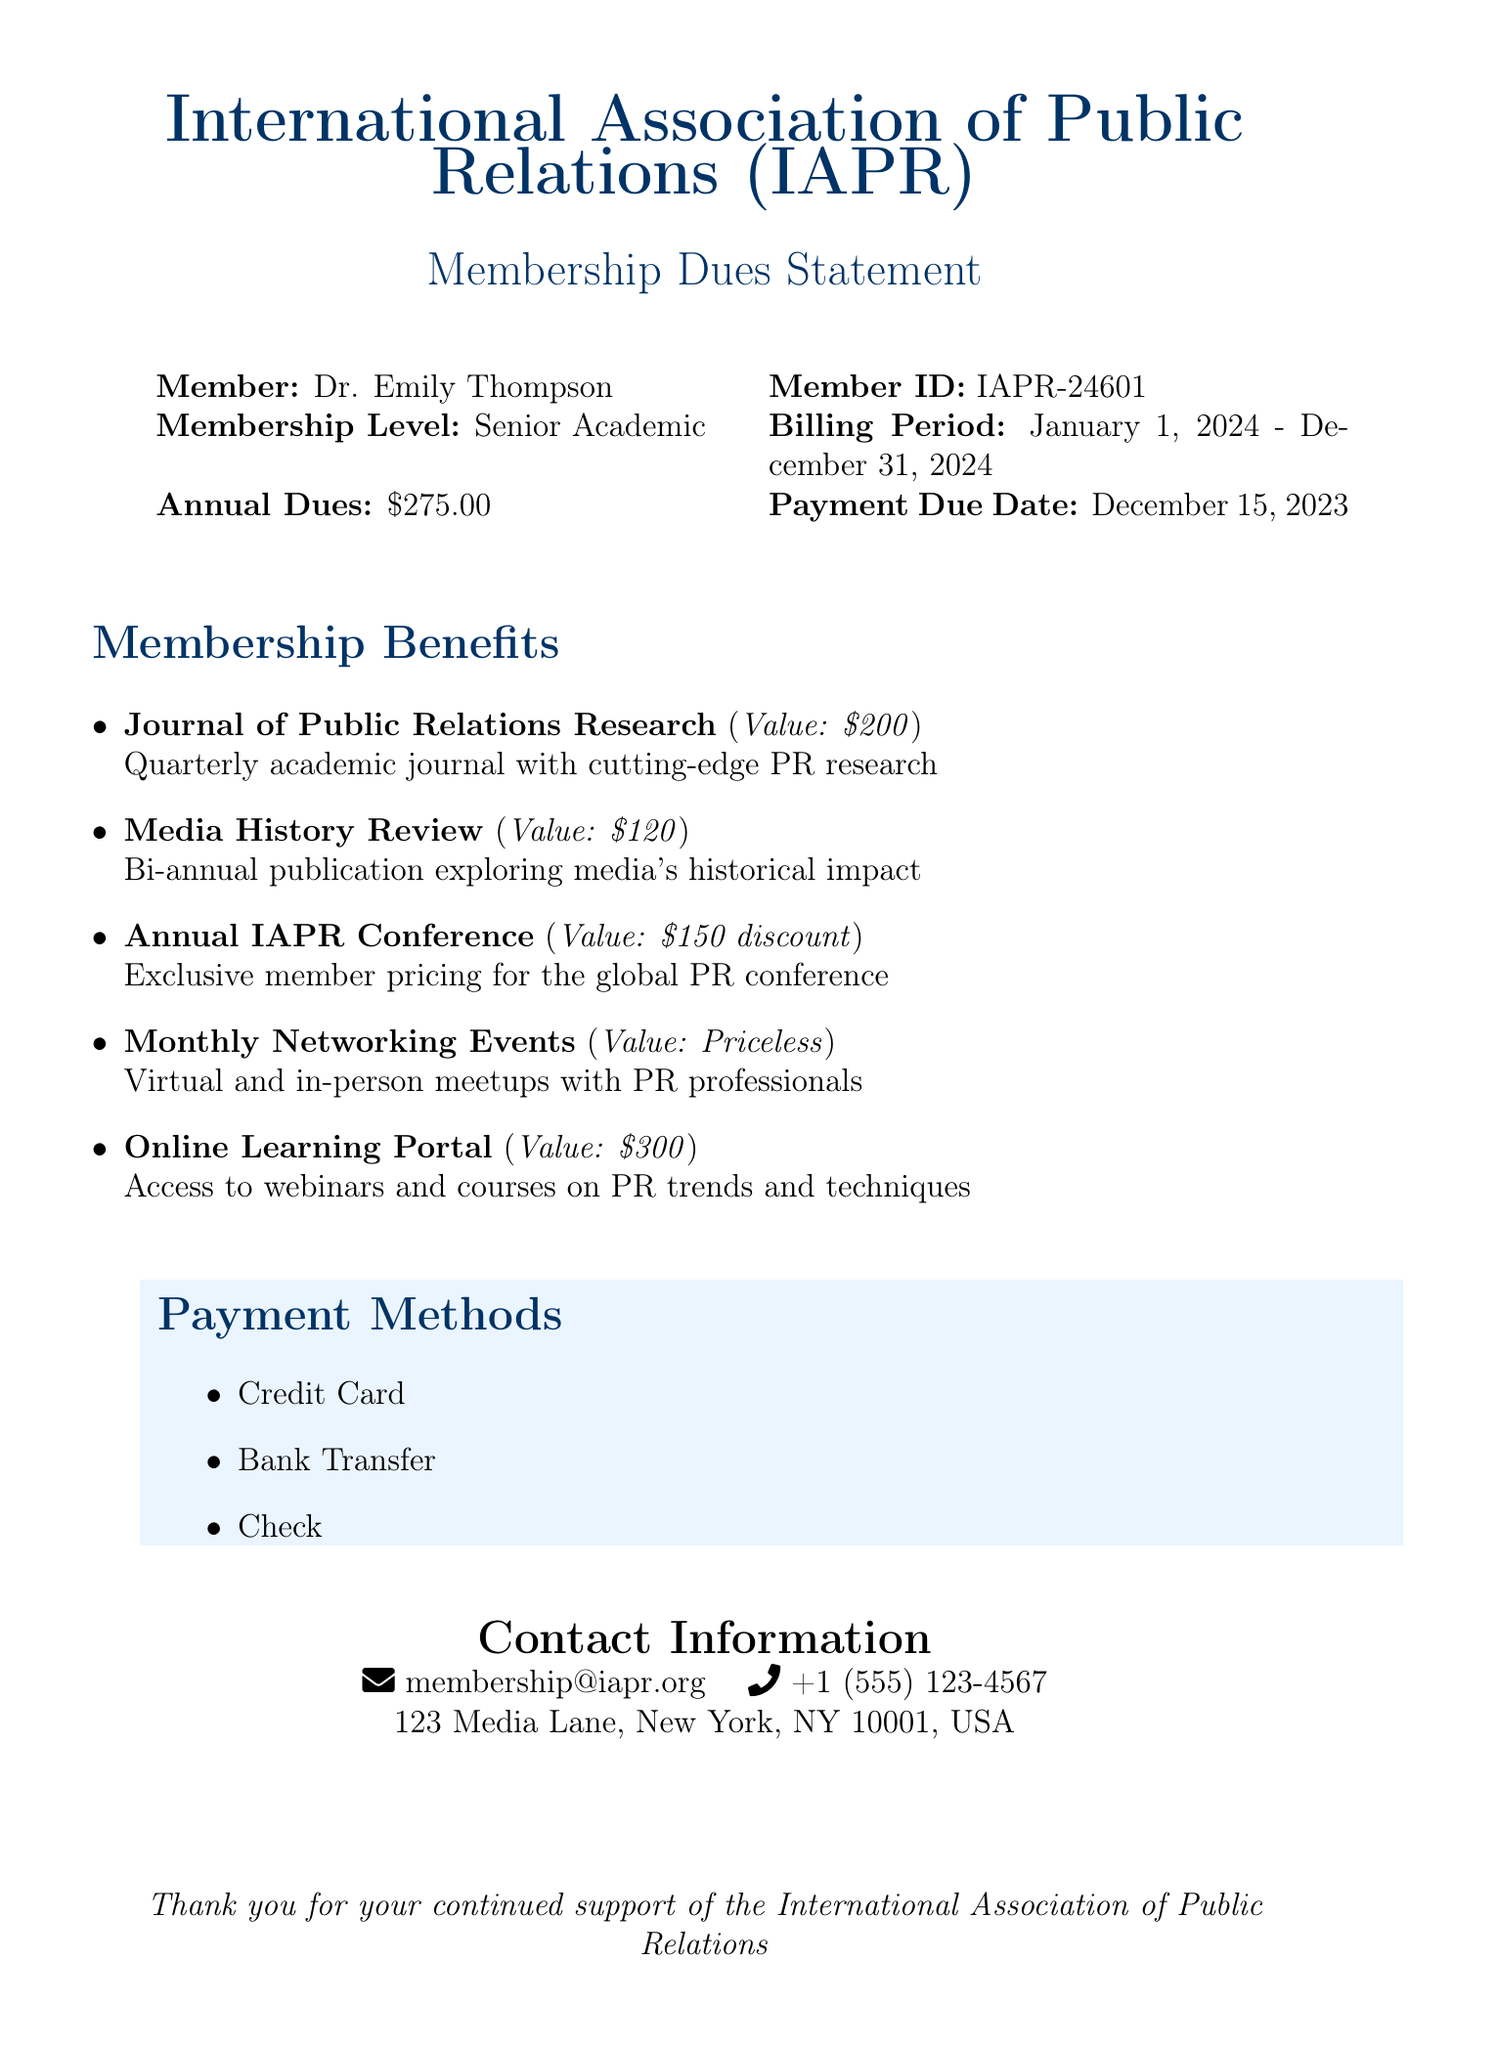What are the annual dues? The annual dues listed in the document are explicitly stated as $275.00.
Answer: $275.00 What is the billing period? The document specifies the billing period as January 1, 2024 - December 31, 2024.
Answer: January 1, 2024 - December 31, 2024 What is one benefit from the membership? The document lists multiple benefits; "Journal of Public Relations Research" is one of them.
Answer: Journal of Public Relations Research What is the payment due date? The date when payment is due is provided as December 15, 2023.
Answer: December 15, 2023 What discount do members receive for the Annual IAPR Conference? The document mentions a discount of $150 for members attending the conference.
Answer: $150 discount How often is the Media History Review published? The document indicates that it is published bi-annually.
Answer: Bi-annual What is the contact email provided in the document? The email listed for membership inquiries is mentioned as membership@iapr.org.
Answer: membership@iapr.org What type of learning resources can members access? The document states that members have access to an online learning portal, including webinars and courses.
Answer: Online Learning Portal What are the payment methods available? The document lists credit card, bank transfer, and check as payment methods.
Answer: Credit Card, Bank Transfer, Check 